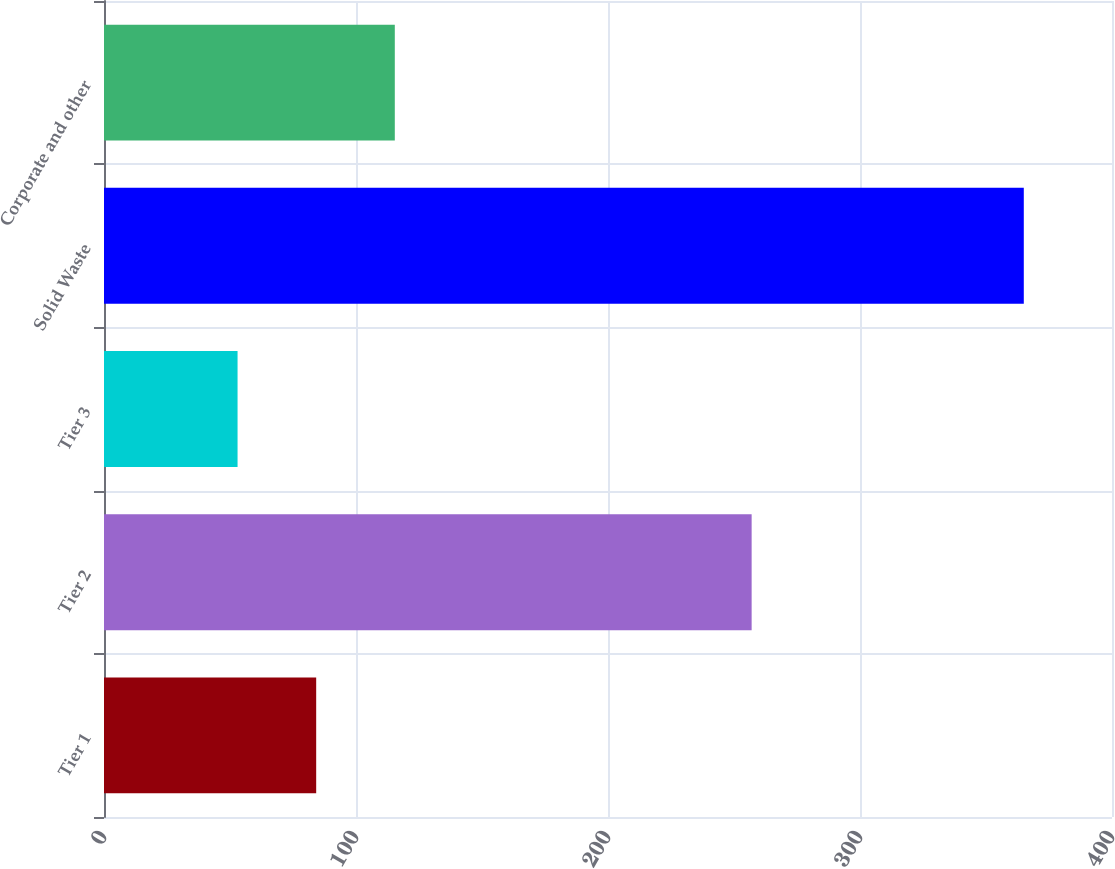Convert chart. <chart><loc_0><loc_0><loc_500><loc_500><bar_chart><fcel>Tier 1<fcel>Tier 2<fcel>Tier 3<fcel>Solid Waste<fcel>Corporate and other<nl><fcel>84.2<fcel>257<fcel>53<fcel>365<fcel>115.4<nl></chart> 